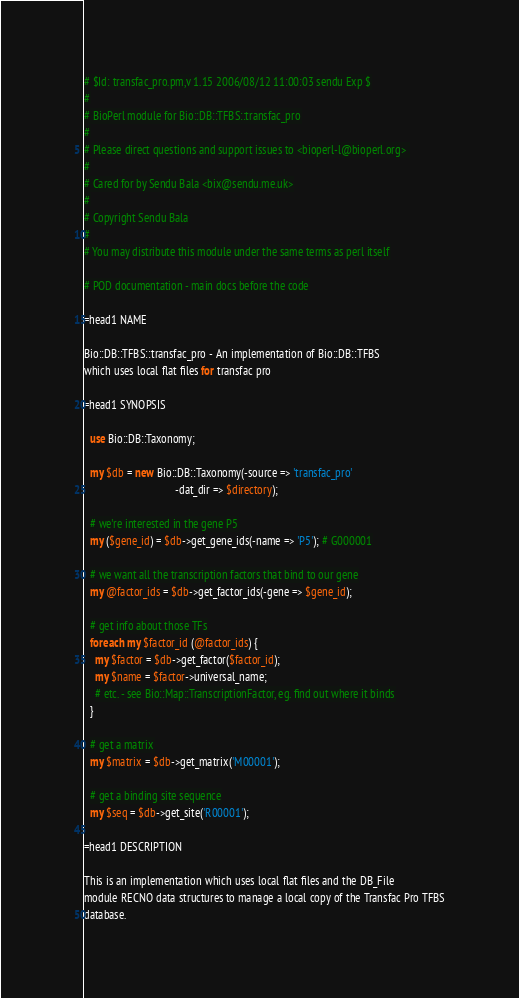Convert code to text. <code><loc_0><loc_0><loc_500><loc_500><_Perl_># $Id: transfac_pro.pm,v 1.15 2006/08/12 11:00:03 sendu Exp $
#
# BioPerl module for Bio::DB::TFBS::transfac_pro
#
# Please direct questions and support issues to <bioperl-l@bioperl.org> 
#
# Cared for by Sendu Bala <bix@sendu.me.uk>
#
# Copyright Sendu Bala
#
# You may distribute this module under the same terms as perl itself

# POD documentation - main docs before the code

=head1 NAME

Bio::DB::TFBS::transfac_pro - An implementation of Bio::DB::TFBS
which uses local flat files for transfac pro

=head1 SYNOPSIS

  use Bio::DB::Taxonomy;

  my $db = new Bio::DB::Taxonomy(-source => 'transfac_pro'
                                 -dat_dir => $directory);

  # we're interested in the gene P5
  my ($gene_id) = $db->get_gene_ids(-name => 'P5'); # G000001

  # we want all the transcription factors that bind to our gene
  my @factor_ids = $db->get_factor_ids(-gene => $gene_id);

  # get info about those TFs
  foreach my $factor_id (@factor_ids) {
    my $factor = $db->get_factor($factor_id);
    my $name = $factor->universal_name;
    # etc. - see Bio::Map::TranscriptionFactor, eg. find out where it binds
  }

  # get a matrix
  my $matrix = $db->get_matrix('M00001');

  # get a binding site sequence
  my $seq = $db->get_site('R00001');

=head1 DESCRIPTION

This is an implementation which uses local flat files and the DB_File
module RECNO data structures to manage a local copy of the Transfac Pro TFBS
database.
</code> 